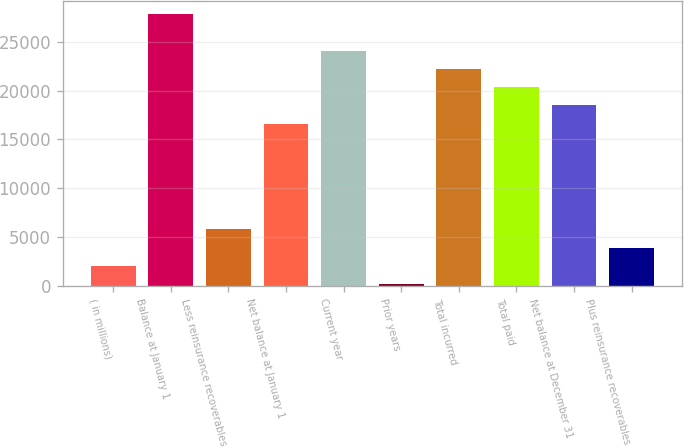Convert chart to OTSL. <chart><loc_0><loc_0><loc_500><loc_500><bar_chart><fcel>( in millions)<fcel>Balance at January 1<fcel>Less reinsurance recoverables<fcel>Net balance at January 1<fcel>Current year<fcel>Prior years<fcel>Total incurred<fcel>Total paid<fcel>Net balance at December 31<fcel>Plus reinsurance recoverables<nl><fcel>2041.4<fcel>27826.4<fcel>5780.2<fcel>16610<fcel>24087.6<fcel>172<fcel>22218.2<fcel>20348.8<fcel>18479.4<fcel>3910.8<nl></chart> 